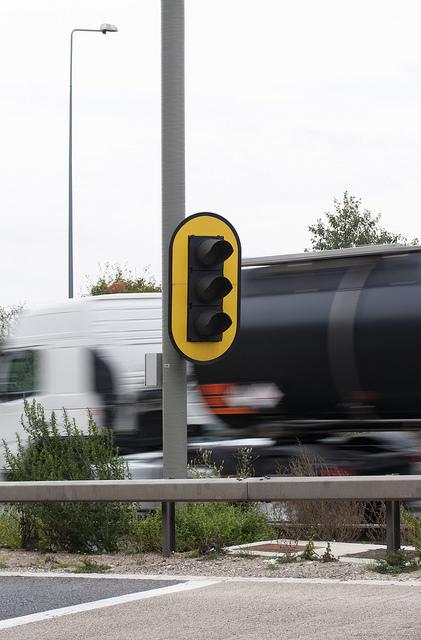Is there a  picture of  a road sign?
Be succinct. No. What is in the background?
Answer briefly. Train. How many street lights can be seen?
Quick response, please. 1. 